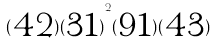<formula> <loc_0><loc_0><loc_500><loc_500>( \begin{matrix} 4 2 \end{matrix} ) { ( \begin{matrix} 3 1 \end{matrix} ) } ^ { 2 } ( \begin{matrix} 9 1 \end{matrix} ) ( \begin{matrix} 4 3 \end{matrix} )</formula> 